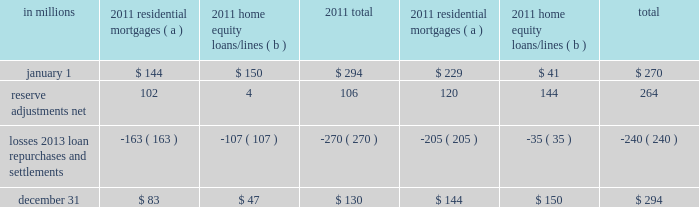Agreements associated with the agency securitizations , most sale agreements do not provide for penalties or other remedies if we do not respond timely to investor indemnification or repurchase requests .
Origination and sale of residential mortgages is an ongoing business activity and , accordingly , management continually assesses the need to recognize indemnification and repurchase liabilities pursuant to the associated investor sale agreements .
We establish indemnification and repurchase liabilities for estimated losses on sold first and second-lien mortgages and home equity loans/lines for which indemnification is expected to be provided or for loans that are expected to be repurchased .
For the first and second-lien mortgage sold portfolio , we have established an indemnification and repurchase liability pursuant to investor sale agreements based on claims made and our estimate of future claims on a loan by loan basis .
These relate primarily to loans originated during 2006-2008 .
For the home equity loans/lines sold portfolio , we have established indemnification and repurchase liabilities based upon this same methodology for loans sold during 2005-2007 .
Indemnification and repurchase liabilities are initially recognized when loans are sold to investors and are subsequently evaluated by management .
Initial recognition and subsequent adjustments to the indemnification and repurchase liability for the sold residential mortgage portfolio are recognized in residential mortgage revenue on the consolidated income statement .
Since pnc is no longer engaged in the brokered home equity lending business , only subsequent adjustments are recognized to the home equity loans/lines indemnification and repurchase liability .
These adjustments are recognized in other noninterest income on the consolidated income statement .
Management 2019s subsequent evaluation of these indemnification and repurchase liabilities is based upon trends in indemnification and repurchase requests , actual loss experience , risks in the underlying serviced loan portfolios , and current economic conditions .
As part of its evaluation , management considers estimated loss projections over the life of the subject loan portfolio .
At december 31 , 2011 and december 31 , 2010 , the total indemnification and repurchase liability for estimated losses on indemnification and repurchase claims totaled $ 130 million and $ 294 million , respectively , and was included in other liabilities on the consolidated balance sheet .
An analysis of the changes in this liability during 2011 and 2010 follows : analysis of indemnification and repurchase liability for asserted claims and unasserted claims .
( a ) repurchase obligation associated with sold loan portfolios of $ 121.4 billion and $ 139.8 billion at december 31 , 2011 and december 31 , 2010 , respectively .
( b ) repurchase obligation associated with sold loan portfolios of $ 4.5 billion and $ 6.5 billion at december 31 , 2011 and december 31 , 2010 , respectively .
Pnc is no longer engaged in the brokered home equity lending business , which was acquired with national city .
Management believes our indemnification and repurchase liabilities appropriately reflect the estimated probable losses on investor indemnification and repurchase claims at december 31 , 2011 and 2010 .
While management seeks to obtain all relevant information in estimating the indemnification and repurchase liability , the estimation process is inherently uncertain and imprecise and , accordingly , it is reasonably possible that future indemnification and repurchase losses could be more or less than our established liability .
Factors that could affect our estimate include the volume of valid claims driven by investor strategies and behavior , our ability to successfully negotiate claims with investors , housing prices , and other economic conditions .
At december 31 , 2011 , we estimate that it is reasonably possible that we could incur additional losses in excess of our indemnification and repurchase liability of up to $ 85 million .
This estimate of potential additional losses in excess of our liability is based on assumed higher investor demands , lower claim rescissions , and lower home prices than our current assumptions .
Reinsurance agreements we have two wholly-owned captive insurance subsidiaries which provide reinsurance to third-party insurers related to insurance sold to our customers .
These subsidiaries enter into various types of reinsurance agreements with third-party insurers where the subsidiary assumes the risk of loss through either an excess of loss or quota share agreement up to 100% ( 100 % ) reinsurance .
In excess of loss agreements , these subsidiaries assume the risk of loss for an excess layer of coverage up to specified limits , once a defined first loss percentage is met .
In quota share agreements , the subsidiaries and third-party insurers share the responsibility for payment of all claims .
These subsidiaries provide reinsurance for accidental death & dismemberment , credit life , accident & health , lender placed 200 the pnc financial services group , inc .
2013 form 10-k .
Home equity loans were what percent of the total indemnification and repurchase liability for asserted claims and unasserted claims as of december 31 2011? 
Computations: (47 / 130)
Answer: 0.36154. 